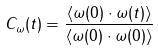<formula> <loc_0><loc_0><loc_500><loc_500>C _ { \omega } ( t ) = \frac { \langle \omega ( 0 ) \cdot \omega ( t ) \rangle } { \langle \omega ( 0 ) \cdot \omega ( 0 ) \rangle }</formula> 